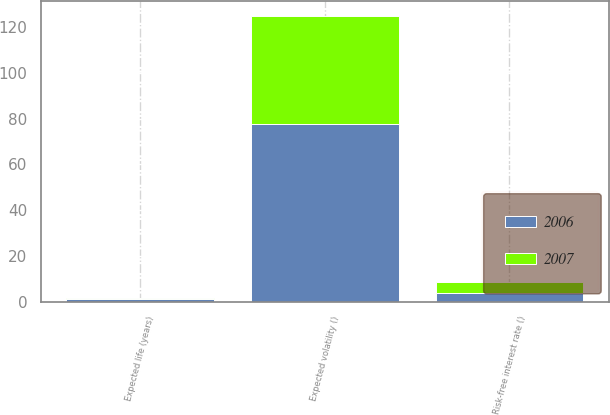Convert chart to OTSL. <chart><loc_0><loc_0><loc_500><loc_500><stacked_bar_chart><ecel><fcel>Expected life (years)<fcel>Risk-free interest rate ()<fcel>Expected volatility ()<nl><fcel>2007<fcel>0.5<fcel>4.6<fcel>47.4<nl><fcel>2006<fcel>1.1<fcel>4<fcel>77.7<nl></chart> 